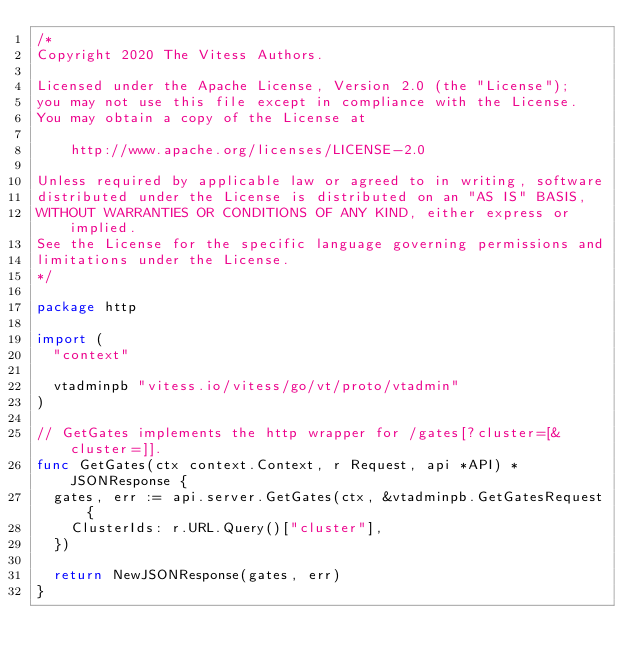<code> <loc_0><loc_0><loc_500><loc_500><_Go_>/*
Copyright 2020 The Vitess Authors.

Licensed under the Apache License, Version 2.0 (the "License");
you may not use this file except in compliance with the License.
You may obtain a copy of the License at

    http://www.apache.org/licenses/LICENSE-2.0

Unless required by applicable law or agreed to in writing, software
distributed under the License is distributed on an "AS IS" BASIS,
WITHOUT WARRANTIES OR CONDITIONS OF ANY KIND, either express or implied.
See the License for the specific language governing permissions and
limitations under the License.
*/

package http

import (
	"context"

	vtadminpb "vitess.io/vitess/go/vt/proto/vtadmin"
)

// GetGates implements the http wrapper for /gates[?cluster=[&cluster=]].
func GetGates(ctx context.Context, r Request, api *API) *JSONResponse {
	gates, err := api.server.GetGates(ctx, &vtadminpb.GetGatesRequest{
		ClusterIds: r.URL.Query()["cluster"],
	})

	return NewJSONResponse(gates, err)
}
</code> 